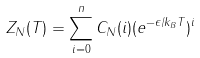<formula> <loc_0><loc_0><loc_500><loc_500>Z _ { N } ( T ) = \sum _ { i = 0 } ^ { n } C _ { N } ( i ) ( e ^ { - \epsilon / k _ { B } T } ) ^ { i }</formula> 